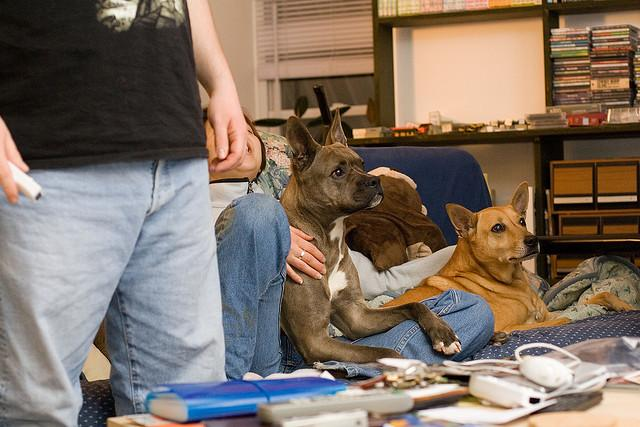Where are these people located?

Choices:
A) work
B) hospital
C) library
D) home home 